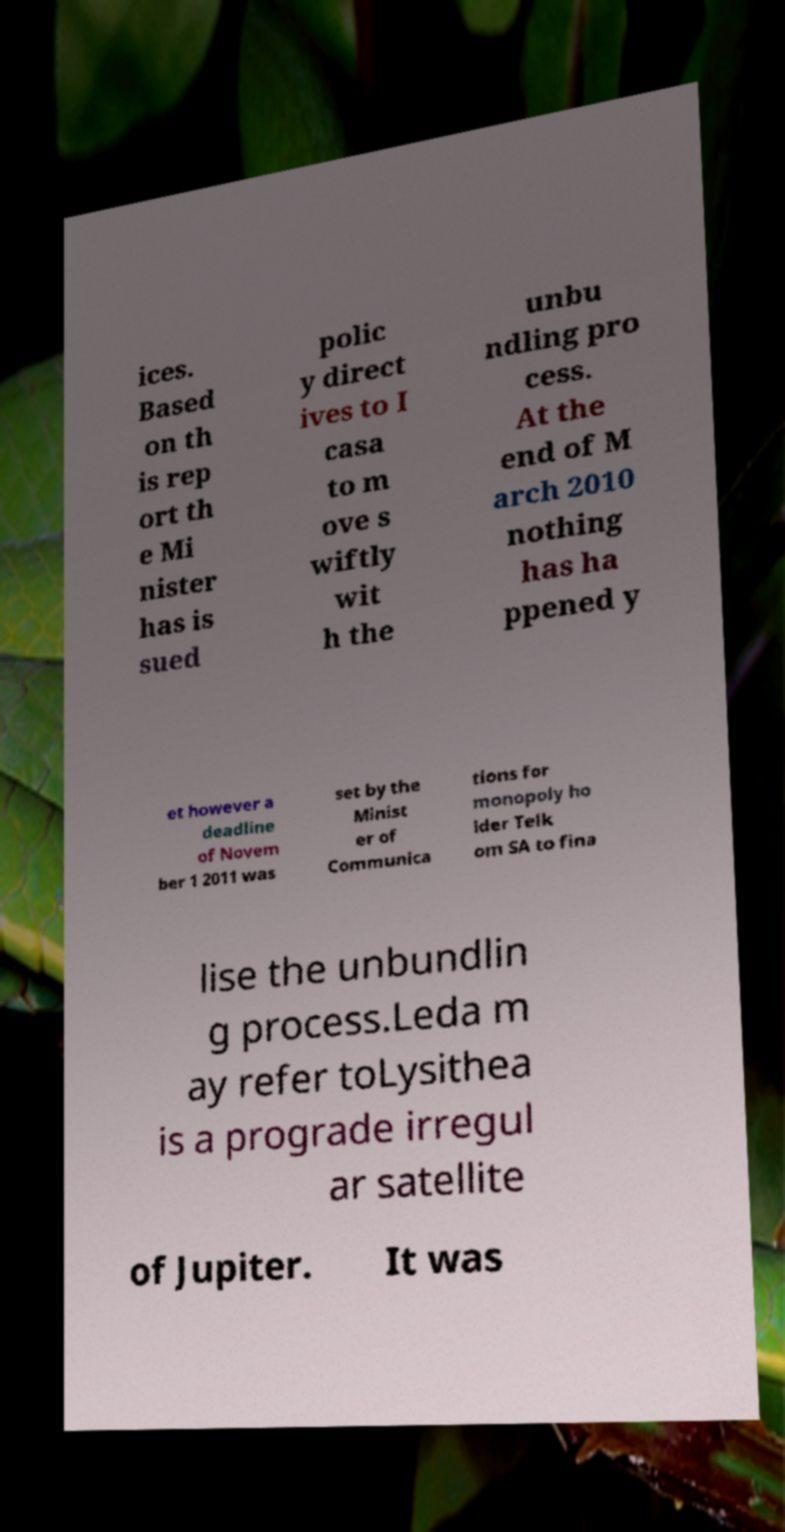For documentation purposes, I need the text within this image transcribed. Could you provide that? ices. Based on th is rep ort th e Mi nister has is sued polic y direct ives to I casa to m ove s wiftly wit h the unbu ndling pro cess. At the end of M arch 2010 nothing has ha ppened y et however a deadline of Novem ber 1 2011 was set by the Minist er of Communica tions for monopoly ho lder Telk om SA to fina lise the unbundlin g process.Leda m ay refer toLysithea is a prograde irregul ar satellite of Jupiter. It was 